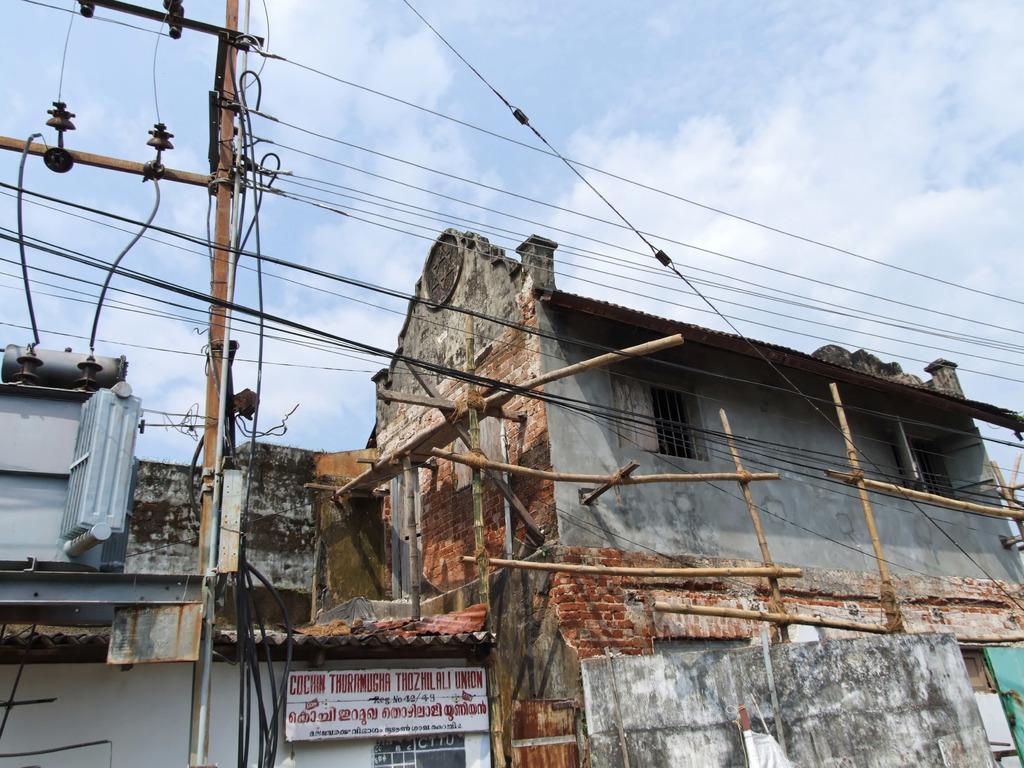In one or two sentences, can you explain what this image depicts? There is a building which is under construction and there is a transformer,pole and some wires in the left corner. 